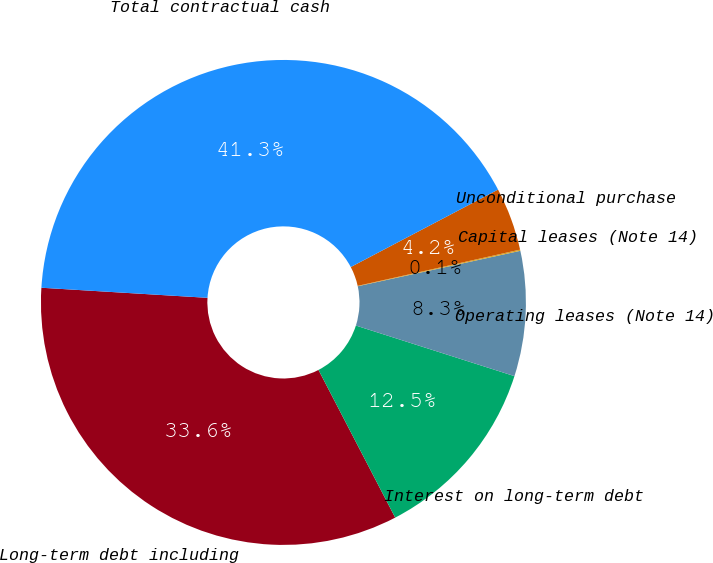Convert chart to OTSL. <chart><loc_0><loc_0><loc_500><loc_500><pie_chart><fcel>Long-term debt including<fcel>Interest on long-term debt<fcel>Operating leases (Note 14)<fcel>Capital leases (Note 14)<fcel>Unconditional purchase<fcel>Total contractual cash<nl><fcel>33.59%<fcel>12.46%<fcel>8.33%<fcel>0.08%<fcel>4.21%<fcel>41.33%<nl></chart> 